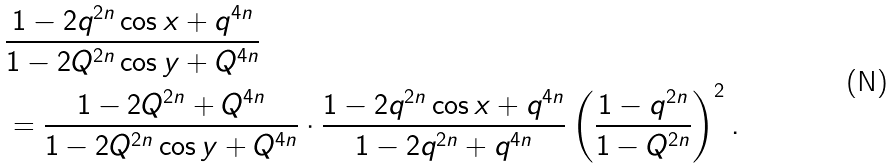<formula> <loc_0><loc_0><loc_500><loc_500>& \frac { 1 - 2 q ^ { 2 n } \cos x + q ^ { 4 n } } { 1 - 2 Q ^ { 2 n } \cos y + Q ^ { 4 n } } \\ & = \frac { 1 - 2 Q ^ { 2 n } + Q ^ { 4 n } } { 1 - 2 Q ^ { 2 n } \cos y + Q ^ { 4 n } } \cdot \frac { 1 - 2 q ^ { 2 n } \cos x + q ^ { 4 n } } { 1 - 2 q ^ { 2 n } + q ^ { 4 n } } \left ( \frac { 1 - q ^ { 2 n } } { 1 - Q ^ { 2 n } } \right ) ^ { 2 } .</formula> 